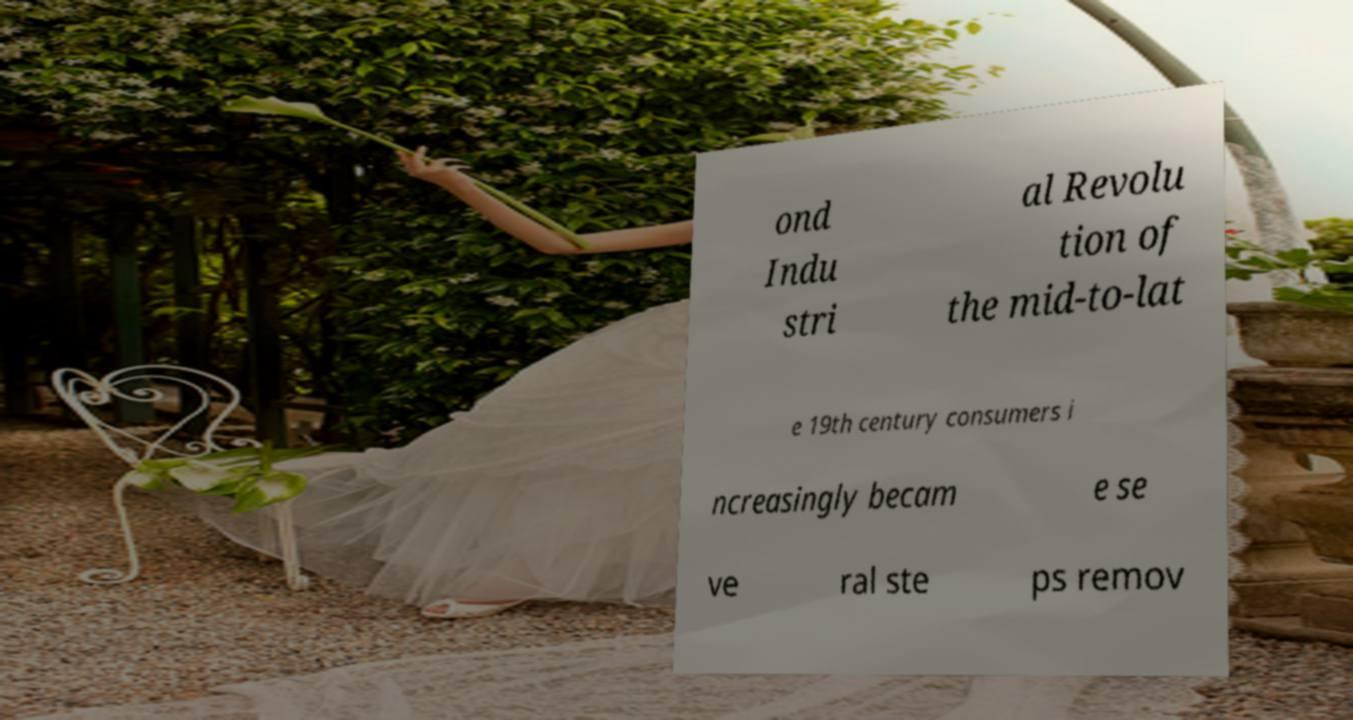For documentation purposes, I need the text within this image transcribed. Could you provide that? ond Indu stri al Revolu tion of the mid-to-lat e 19th century consumers i ncreasingly becam e se ve ral ste ps remov 